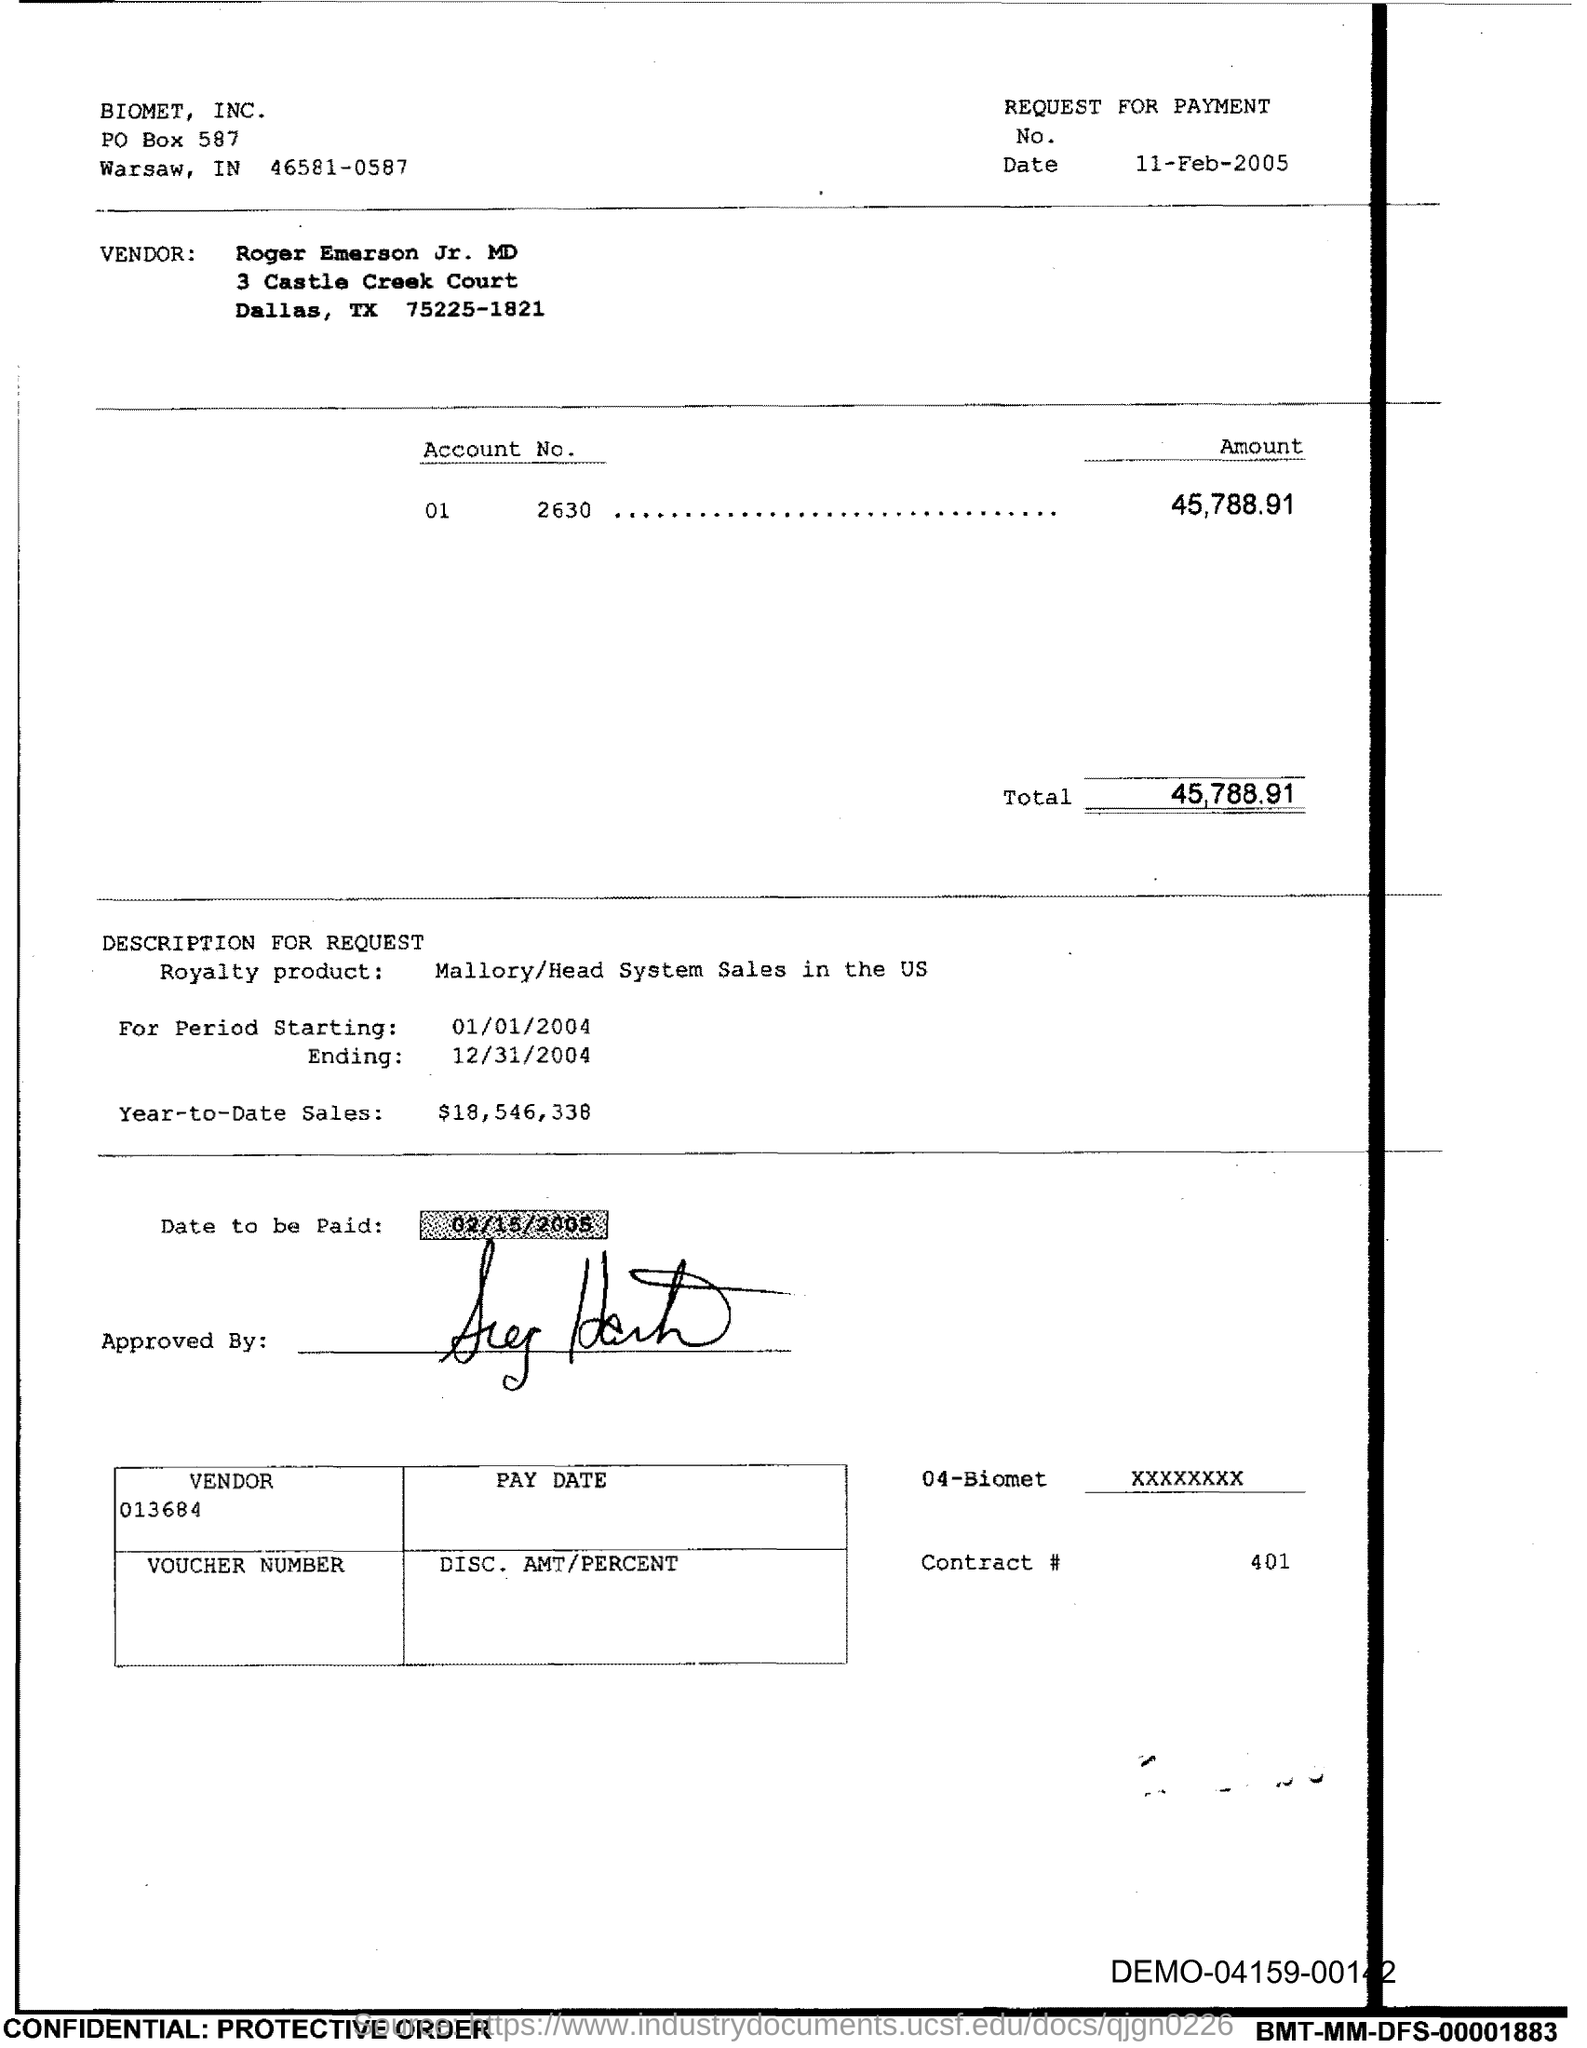What is the Total?
Offer a very short reply. 45,788.91. What is the Contract # Number?
Provide a short and direct response. 401. 